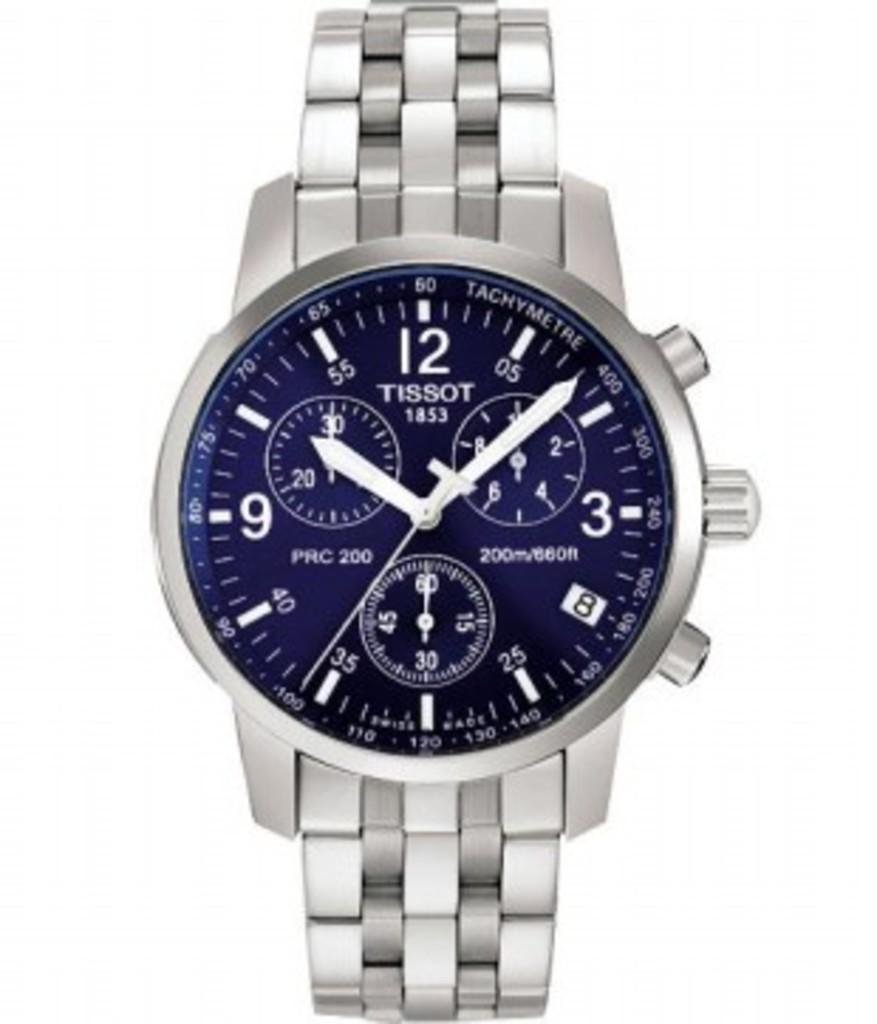What is the brand of this watch?
Offer a terse response. Tissot. What time is the watch showing?
Ensure brevity in your answer.  10:08. 